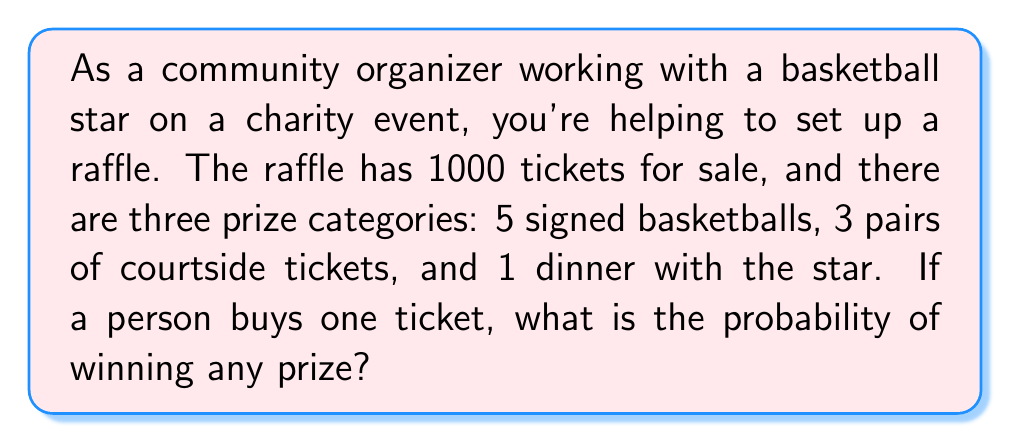Help me with this question. To solve this problem, we need to follow these steps:

1. Determine the total number of winning tickets:
   - Signed basketballs: 5
   - Courtside tickets: 3
   - Dinner with the star: 1
   Total winning tickets = 5 + 3 + 1 = 9

2. Calculate the probability of winning any prize:
   The probability of an event is the number of favorable outcomes divided by the total number of possible outcomes.

   In this case:
   - Favorable outcomes: 9 (total winning tickets)
   - Total possible outcomes: 1000 (total number of tickets)

   Probability = $\frac{\text{Favorable outcomes}}{\text{Total possible outcomes}}$

   $P(\text{winning any prize}) = \frac{9}{1000} = \frac{9}{1000} = 0.009$

3. Convert to a percentage:
   $0.009 \times 100\% = 0.9\%$

Therefore, the probability of winning any prize with one ticket is 0.009 or 0.9%.
Answer: The probability of winning any prize with one ticket is $\frac{9}{1000} = 0.009$ or $0.9\%$. 